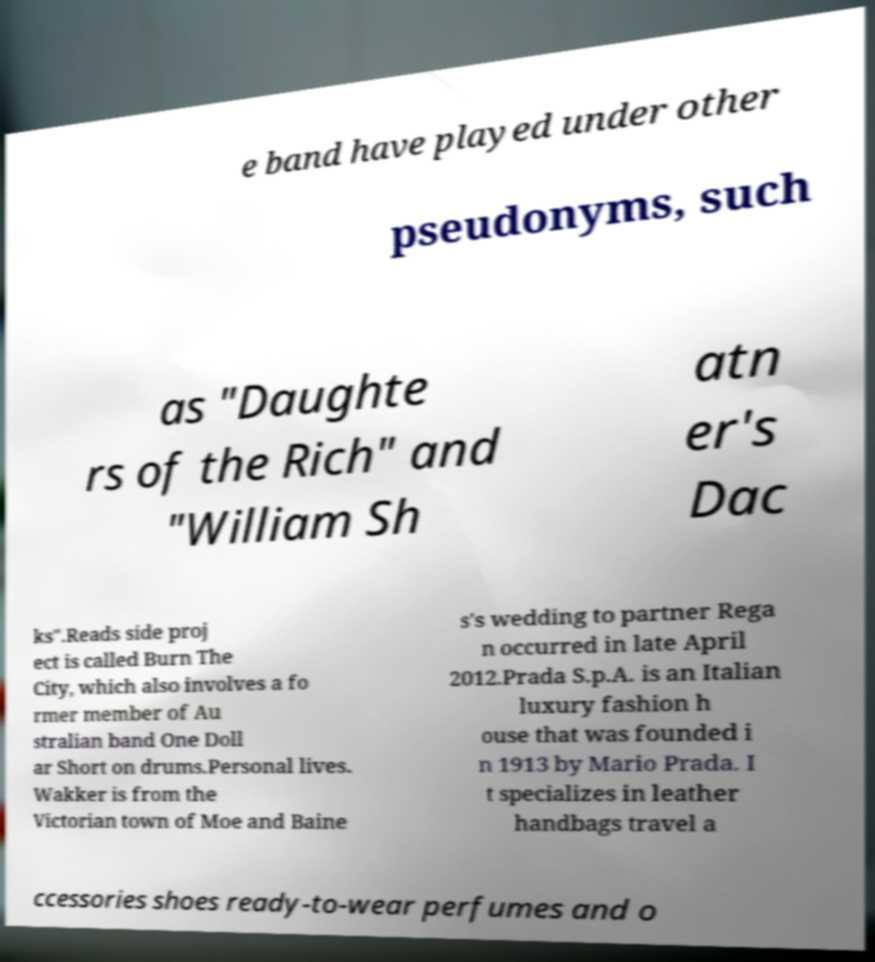Can you read and provide the text displayed in the image?This photo seems to have some interesting text. Can you extract and type it out for me? e band have played under other pseudonyms, such as "Daughte rs of the Rich" and "William Sh atn er's Dac ks".Reads side proj ect is called Burn The City, which also involves a fo rmer member of Au stralian band One Doll ar Short on drums.Personal lives. Wakker is from the Victorian town of Moe and Baine s's wedding to partner Rega n occurred in late April 2012.Prada S.p.A. is an Italian luxury fashion h ouse that was founded i n 1913 by Mario Prada. I t specializes in leather handbags travel a ccessories shoes ready-to-wear perfumes and o 